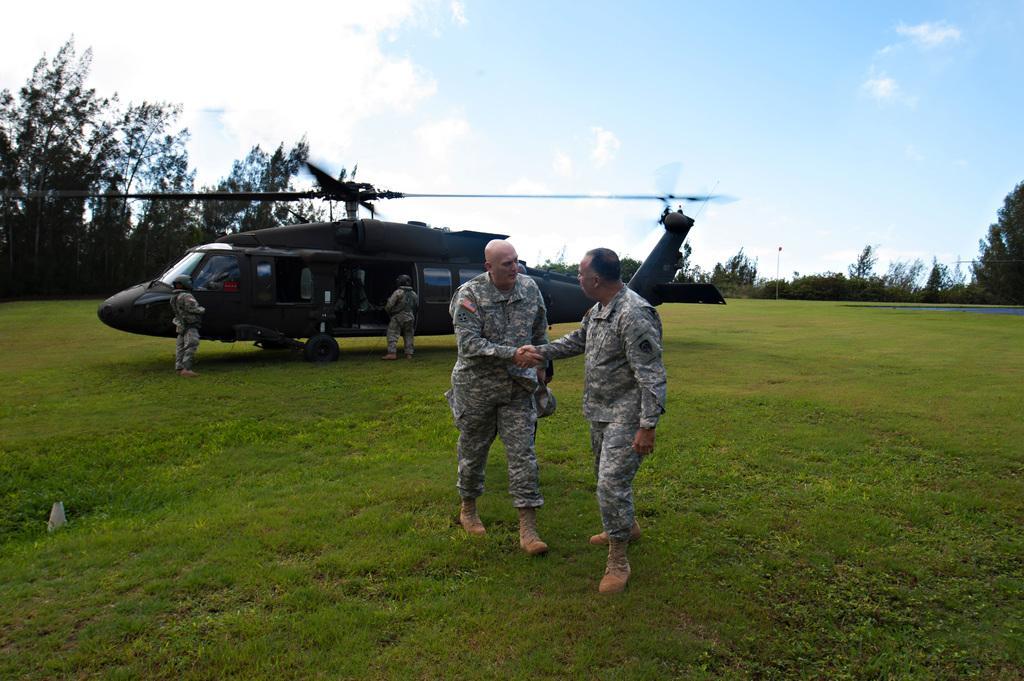Please provide a concise description of this image. In this picture we can see people and a helicopter on the ground and in the background we can see trees, sky. 